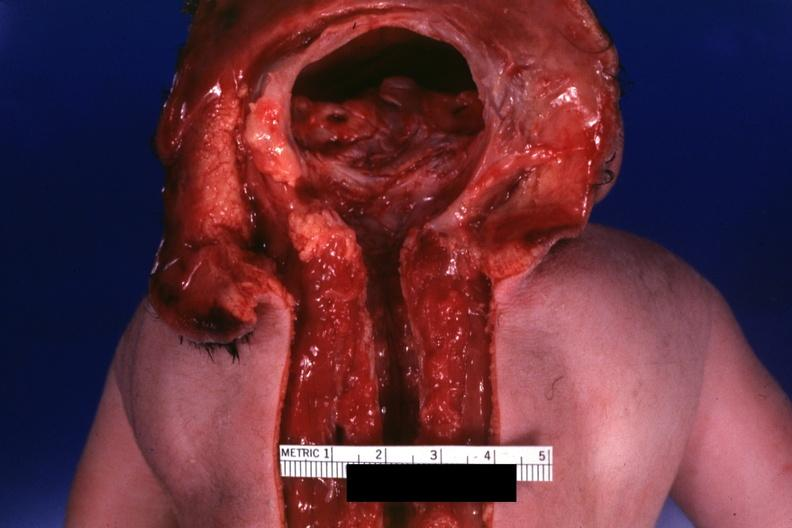s brain present?
Answer the question using a single word or phrase. Yes 